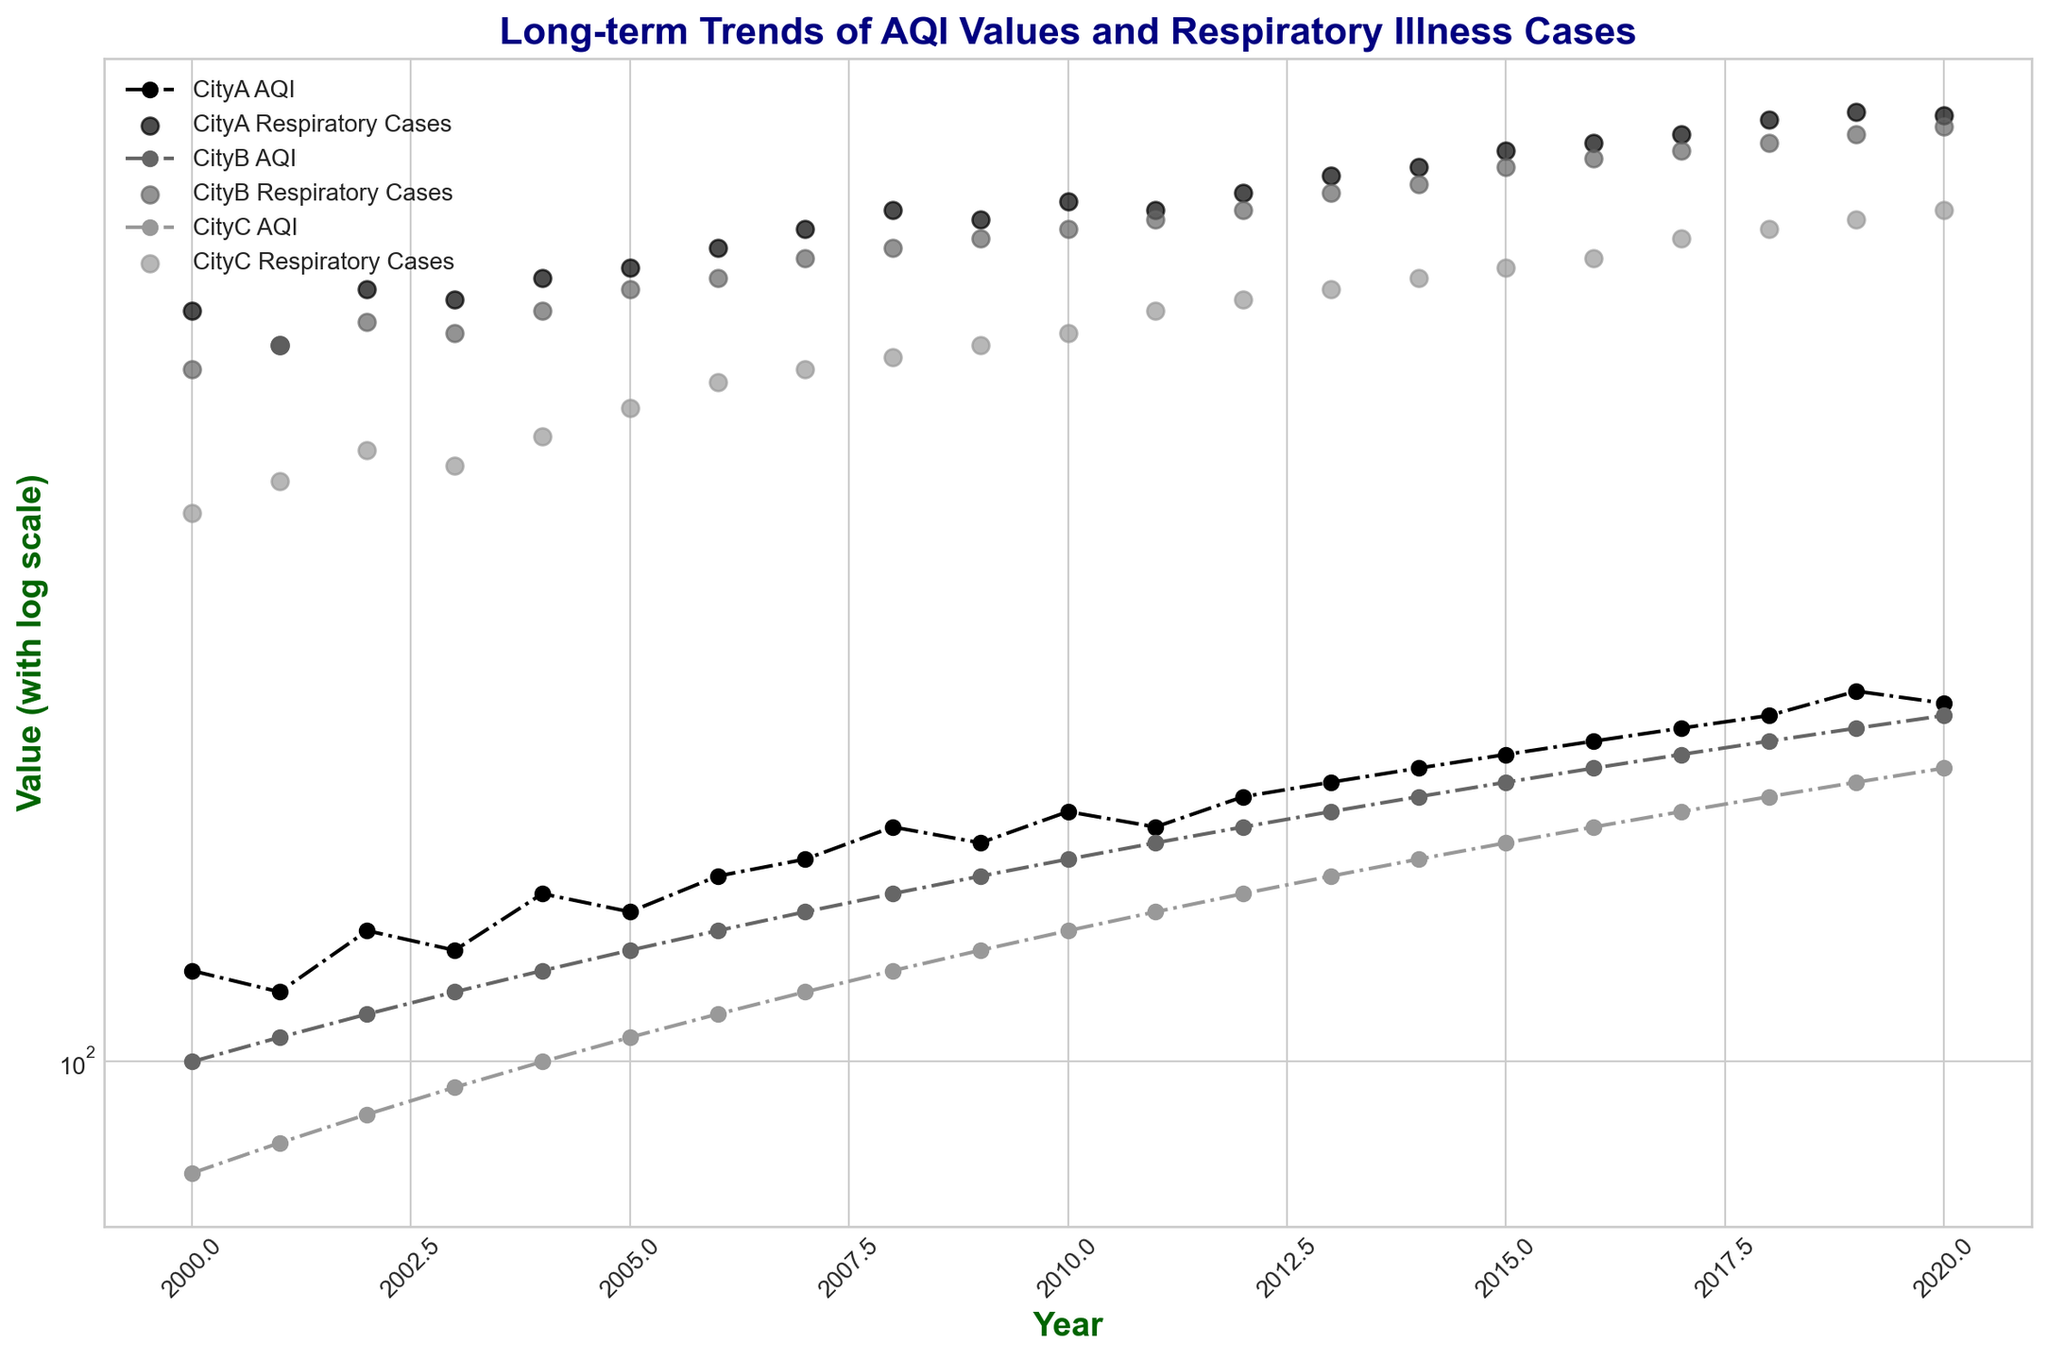Which city has the highest AQI in 2020? By looking at the end of each line representing AQI values for different cities, we find that CityA has an AQI of 205, CityB has an AQI of 200, and CityC has an AQI of 180 in 2020. Therefore, CityA has the highest AQI in 2020.
Answer: CityA Which city experienced the largest increase in respiratory illness cases from 2000 to 2020? CityA started with 450 cases in 2000 and increased to 665 in 2020, which is an increase of 215 cases. CityB started with 400 and ended with 650, an increase of 250 cases. CityC started with 300 and ended with 550, an increase of 250 cases. Both CityB and CityC have the largest increases, tying at 250 cases.
Answer: CityB, CityC Compare the AQI trend lines for CityA and CityB. Which city shows a steadier increase in AQI over time? CityA shows some fluctuations but generally increases from around 120 in 2000 to 205 in 2020. On the other hand, CityB shows a steadier increase in its AQI values, starting from around 100 in 2000 to 200 in 2020, with fewer visible fluctuations.
Answer: CityB What year did CityC's AQI value first reach or exceed CityA's AQI value from the previous year? CityC's AQI reaches 150 in 2014, while CityA's AQI was 140 in 2004. This shows that CityC's AQI in 2014 exceeded CityA's AQI from 2004, meeting the criteria for the previous year's value as an annual trend is considered.
Answer: 2014 Are there any years where all three cities had almost the same AQI values? By checking visually, we see that around 2004, CityA had an AQI close to 140, CityB close to 120, and CityC around 100. They are not equal but relatively close in range compared to other years. More closely, in 2020, the values for CityA are 205, CityB 200, and CityC 180, which are closer and almost overlapping considering a log scale.
Answer: 2020 What is the trend shown by the respiratory illness cases scatter for CityB? The scatter points for respiratory illness cases in CityB show an upward trend from 400 in 2000 to 650 in 2020, indicating an increase in respiratory illness cases over time.
Answer: Increasing trend Compare the trends of AQI values and respiratory illness cases in CityC. Are they proportional? Both AQI values and respiratory illness cases in CityC show an increasing trend. AQI rises from 80 to 180, and respiratory illness cases increase from 300 to 550. This suggests a proportional relationship where as AQI increases, respiratory illness cases also rise.
Answer: Yes Which city had the lowest AQI in 2010, and what were the corresponding respiratory illness cases? By examining the marks for the year 2010, CityC has the lowest AQI of 130. The corresponding respiratory illness cases for CityC in that year are 430.
Answer: CityC, 430 